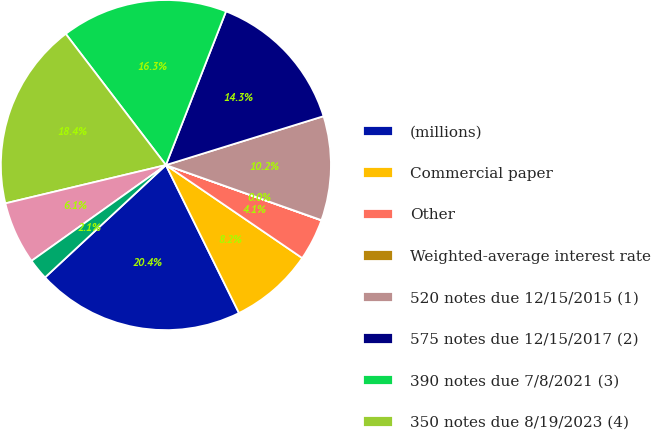Convert chart to OTSL. <chart><loc_0><loc_0><loc_500><loc_500><pie_chart><fcel>(millions)<fcel>Commercial paper<fcel>Other<fcel>Weighted-average interest rate<fcel>520 notes due 12/15/2015 (1)<fcel>575 notes due 12/15/2017 (2)<fcel>390 notes due 7/8/2021 (3)<fcel>350 notes due 8/19/2023 (4)<fcel>763-812 notes due 2024<fcel>fair value adjustments<nl><fcel>20.38%<fcel>8.17%<fcel>4.09%<fcel>0.02%<fcel>10.2%<fcel>14.28%<fcel>16.31%<fcel>18.35%<fcel>6.13%<fcel>2.06%<nl></chart> 